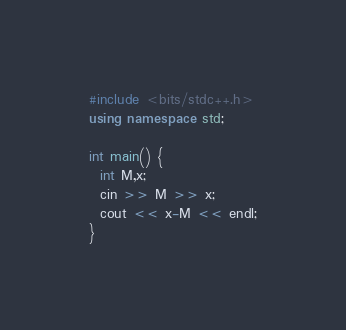Convert code to text. <code><loc_0><loc_0><loc_500><loc_500><_C++_>#include <bits/stdc++.h>
using namespace std;

int main() {
  int M,x;
  cin >> M >> x;
  cout << x-M << endl;
}</code> 